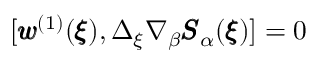Convert formula to latex. <formula><loc_0><loc_0><loc_500><loc_500>[ { \pm b w } ^ { ( 1 ) } ( { \pm b \xi } ) , \Delta _ { \xi } \nabla _ { \beta } { \pm b S } _ { \alpha } ( { \pm b \xi } ) ] = 0</formula> 